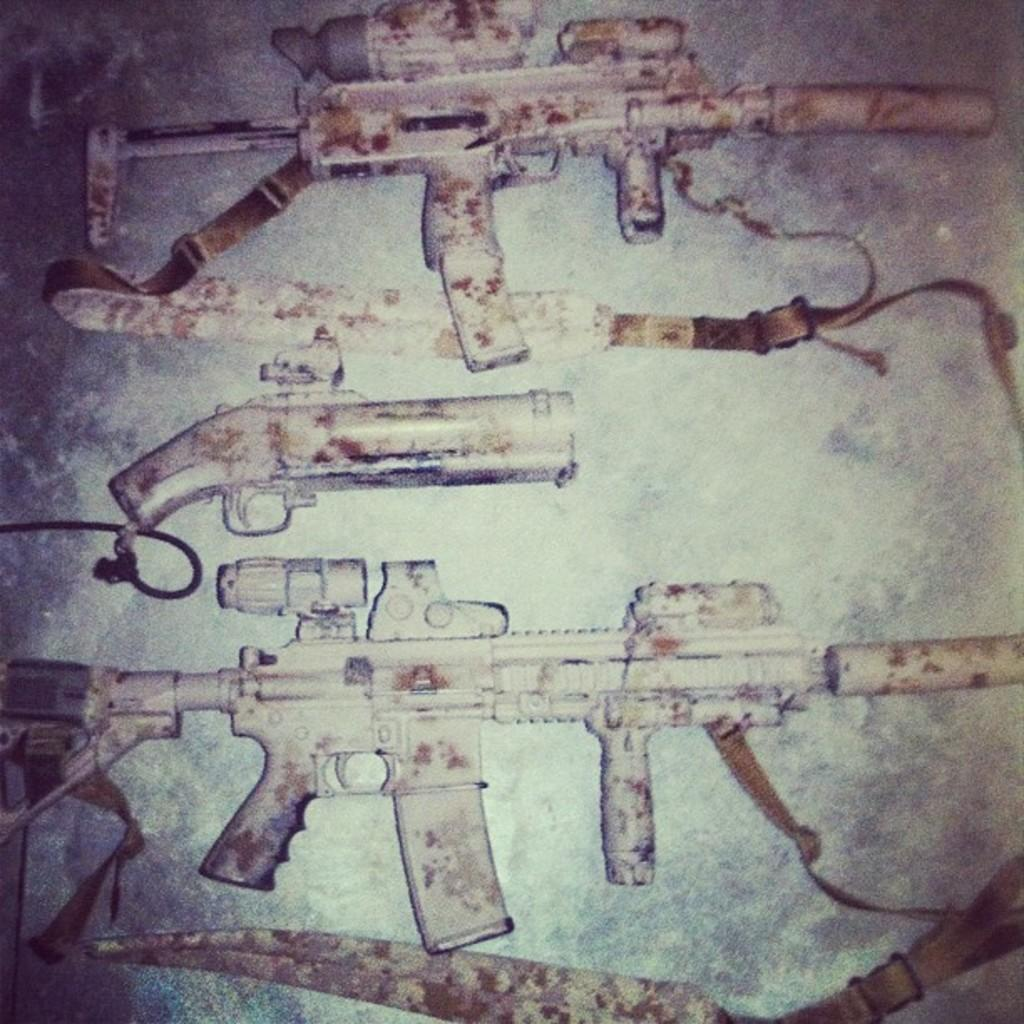What objects are present in the image? There are weapons in the image. Where are the weapons placed? The weapons are kept on a surface. What can be observed on the weapons? There are white color patches on the weapons. Are there any snakes slithering on the stage in the image? There is no stage or snakes present in the image; it features weapons with white color patches on a surface. 